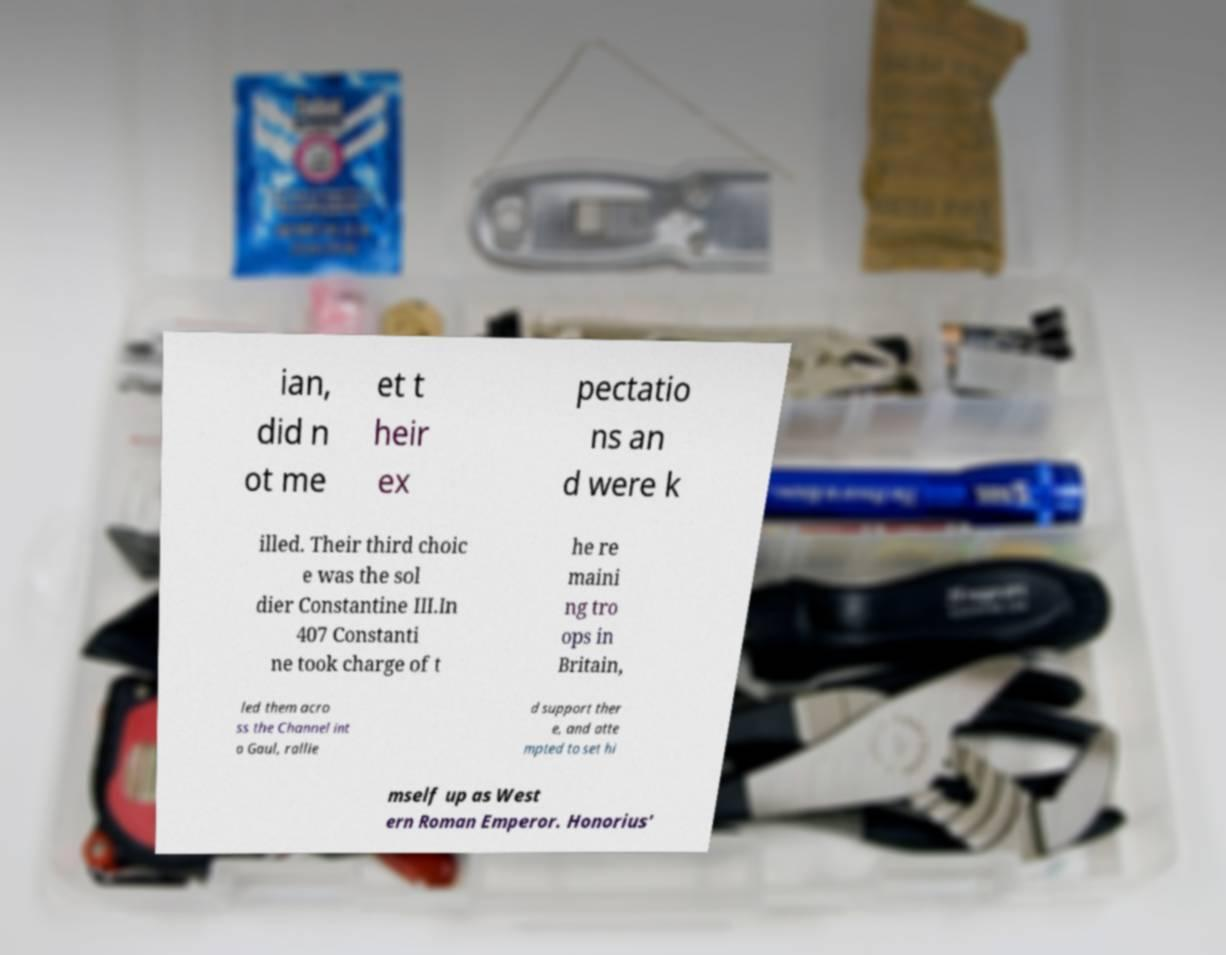What messages or text are displayed in this image? I need them in a readable, typed format. ian, did n ot me et t heir ex pectatio ns an d were k illed. Their third choic e was the sol dier Constantine III.In 407 Constanti ne took charge of t he re maini ng tro ops in Britain, led them acro ss the Channel int o Gaul, rallie d support ther e, and atte mpted to set hi mself up as West ern Roman Emperor. Honorius' 